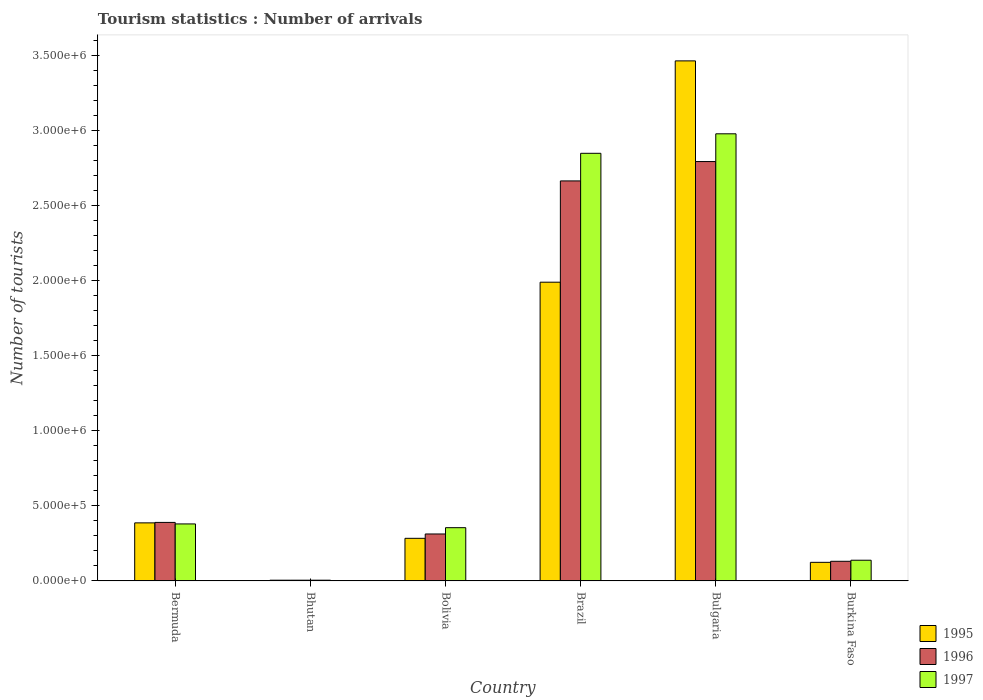How many different coloured bars are there?
Provide a short and direct response. 3. In how many cases, is the number of bars for a given country not equal to the number of legend labels?
Offer a very short reply. 0. What is the number of tourist arrivals in 1995 in Bulgaria?
Offer a terse response. 3.47e+06. Across all countries, what is the maximum number of tourist arrivals in 1997?
Make the answer very short. 2.98e+06. In which country was the number of tourist arrivals in 1995 maximum?
Your answer should be very brief. Bulgaria. In which country was the number of tourist arrivals in 1996 minimum?
Provide a short and direct response. Bhutan. What is the total number of tourist arrivals in 1995 in the graph?
Give a very brief answer. 6.26e+06. What is the difference between the number of tourist arrivals in 1997 in Bhutan and that in Bolivia?
Your answer should be very brief. -3.50e+05. What is the difference between the number of tourist arrivals in 1996 in Bhutan and the number of tourist arrivals in 1997 in Bermuda?
Your answer should be very brief. -3.75e+05. What is the average number of tourist arrivals in 1997 per country?
Offer a terse response. 1.12e+06. What is the difference between the number of tourist arrivals of/in 1996 and number of tourist arrivals of/in 1995 in Burkina Faso?
Your answer should be compact. 7000. In how many countries, is the number of tourist arrivals in 1997 greater than 2600000?
Provide a succinct answer. 2. What is the ratio of the number of tourist arrivals in 1996 in Bulgaria to that in Burkina Faso?
Your response must be concise. 21.34. Is the difference between the number of tourist arrivals in 1996 in Brazil and Bulgaria greater than the difference between the number of tourist arrivals in 1995 in Brazil and Bulgaria?
Keep it short and to the point. Yes. What is the difference between the highest and the second highest number of tourist arrivals in 1997?
Offer a very short reply. 2.60e+06. What is the difference between the highest and the lowest number of tourist arrivals in 1995?
Offer a very short reply. 3.46e+06. In how many countries, is the number of tourist arrivals in 1995 greater than the average number of tourist arrivals in 1995 taken over all countries?
Offer a very short reply. 2. Is the sum of the number of tourist arrivals in 1995 in Bermuda and Bolivia greater than the maximum number of tourist arrivals in 1997 across all countries?
Offer a very short reply. No. Is it the case that in every country, the sum of the number of tourist arrivals in 1995 and number of tourist arrivals in 1997 is greater than the number of tourist arrivals in 1996?
Offer a terse response. Yes. How many countries are there in the graph?
Make the answer very short. 6. What is the difference between two consecutive major ticks on the Y-axis?
Provide a short and direct response. 5.00e+05. Does the graph contain grids?
Offer a terse response. No. How many legend labels are there?
Keep it short and to the point. 3. What is the title of the graph?
Your answer should be very brief. Tourism statistics : Number of arrivals. What is the label or title of the X-axis?
Your response must be concise. Country. What is the label or title of the Y-axis?
Keep it short and to the point. Number of tourists. What is the Number of tourists in 1995 in Bermuda?
Provide a short and direct response. 3.87e+05. What is the Number of tourists in 1995 in Bhutan?
Your answer should be compact. 5000. What is the Number of tourists of 1995 in Bolivia?
Offer a very short reply. 2.84e+05. What is the Number of tourists of 1996 in Bolivia?
Give a very brief answer. 3.13e+05. What is the Number of tourists in 1997 in Bolivia?
Your answer should be very brief. 3.55e+05. What is the Number of tourists in 1995 in Brazil?
Your answer should be compact. 1.99e+06. What is the Number of tourists of 1996 in Brazil?
Offer a terse response. 2.67e+06. What is the Number of tourists in 1997 in Brazil?
Provide a succinct answer. 2.85e+06. What is the Number of tourists of 1995 in Bulgaria?
Make the answer very short. 3.47e+06. What is the Number of tourists of 1996 in Bulgaria?
Offer a very short reply. 2.80e+06. What is the Number of tourists of 1997 in Bulgaria?
Offer a very short reply. 2.98e+06. What is the Number of tourists of 1995 in Burkina Faso?
Keep it short and to the point. 1.24e+05. What is the Number of tourists in 1996 in Burkina Faso?
Your response must be concise. 1.31e+05. What is the Number of tourists of 1997 in Burkina Faso?
Your response must be concise. 1.38e+05. Across all countries, what is the maximum Number of tourists in 1995?
Keep it short and to the point. 3.47e+06. Across all countries, what is the maximum Number of tourists of 1996?
Make the answer very short. 2.80e+06. Across all countries, what is the maximum Number of tourists of 1997?
Make the answer very short. 2.98e+06. Across all countries, what is the minimum Number of tourists of 1995?
Give a very brief answer. 5000. Across all countries, what is the minimum Number of tourists in 1997?
Keep it short and to the point. 5000. What is the total Number of tourists of 1995 in the graph?
Your answer should be compact. 6.26e+06. What is the total Number of tourists in 1996 in the graph?
Ensure brevity in your answer.  6.30e+06. What is the total Number of tourists of 1997 in the graph?
Your response must be concise. 6.71e+06. What is the difference between the Number of tourists in 1995 in Bermuda and that in Bhutan?
Keep it short and to the point. 3.82e+05. What is the difference between the Number of tourists in 1996 in Bermuda and that in Bhutan?
Give a very brief answer. 3.85e+05. What is the difference between the Number of tourists of 1997 in Bermuda and that in Bhutan?
Ensure brevity in your answer.  3.75e+05. What is the difference between the Number of tourists of 1995 in Bermuda and that in Bolivia?
Offer a very short reply. 1.03e+05. What is the difference between the Number of tourists of 1996 in Bermuda and that in Bolivia?
Provide a short and direct response. 7.70e+04. What is the difference between the Number of tourists of 1997 in Bermuda and that in Bolivia?
Give a very brief answer. 2.50e+04. What is the difference between the Number of tourists of 1995 in Bermuda and that in Brazil?
Your response must be concise. -1.60e+06. What is the difference between the Number of tourists in 1996 in Bermuda and that in Brazil?
Your answer should be compact. -2.28e+06. What is the difference between the Number of tourists of 1997 in Bermuda and that in Brazil?
Keep it short and to the point. -2.47e+06. What is the difference between the Number of tourists of 1995 in Bermuda and that in Bulgaria?
Make the answer very short. -3.08e+06. What is the difference between the Number of tourists in 1996 in Bermuda and that in Bulgaria?
Your answer should be compact. -2.40e+06. What is the difference between the Number of tourists of 1997 in Bermuda and that in Bulgaria?
Offer a very short reply. -2.60e+06. What is the difference between the Number of tourists of 1995 in Bermuda and that in Burkina Faso?
Your answer should be very brief. 2.63e+05. What is the difference between the Number of tourists of 1996 in Bermuda and that in Burkina Faso?
Provide a succinct answer. 2.59e+05. What is the difference between the Number of tourists of 1997 in Bermuda and that in Burkina Faso?
Provide a succinct answer. 2.42e+05. What is the difference between the Number of tourists of 1995 in Bhutan and that in Bolivia?
Your response must be concise. -2.79e+05. What is the difference between the Number of tourists in 1996 in Bhutan and that in Bolivia?
Provide a short and direct response. -3.08e+05. What is the difference between the Number of tourists in 1997 in Bhutan and that in Bolivia?
Offer a terse response. -3.50e+05. What is the difference between the Number of tourists in 1995 in Bhutan and that in Brazil?
Ensure brevity in your answer.  -1.99e+06. What is the difference between the Number of tourists of 1996 in Bhutan and that in Brazil?
Your response must be concise. -2.66e+06. What is the difference between the Number of tourists of 1997 in Bhutan and that in Brazil?
Offer a terse response. -2.84e+06. What is the difference between the Number of tourists of 1995 in Bhutan and that in Bulgaria?
Your answer should be very brief. -3.46e+06. What is the difference between the Number of tourists in 1996 in Bhutan and that in Bulgaria?
Provide a succinct answer. -2.79e+06. What is the difference between the Number of tourists of 1997 in Bhutan and that in Bulgaria?
Offer a terse response. -2.98e+06. What is the difference between the Number of tourists of 1995 in Bhutan and that in Burkina Faso?
Offer a terse response. -1.19e+05. What is the difference between the Number of tourists in 1996 in Bhutan and that in Burkina Faso?
Make the answer very short. -1.26e+05. What is the difference between the Number of tourists of 1997 in Bhutan and that in Burkina Faso?
Provide a succinct answer. -1.33e+05. What is the difference between the Number of tourists of 1995 in Bolivia and that in Brazil?
Offer a terse response. -1.71e+06. What is the difference between the Number of tourists of 1996 in Bolivia and that in Brazil?
Ensure brevity in your answer.  -2.35e+06. What is the difference between the Number of tourists of 1997 in Bolivia and that in Brazil?
Make the answer very short. -2.50e+06. What is the difference between the Number of tourists of 1995 in Bolivia and that in Bulgaria?
Provide a succinct answer. -3.18e+06. What is the difference between the Number of tourists of 1996 in Bolivia and that in Bulgaria?
Your answer should be very brief. -2.48e+06. What is the difference between the Number of tourists of 1997 in Bolivia and that in Bulgaria?
Provide a short and direct response. -2.62e+06. What is the difference between the Number of tourists of 1995 in Bolivia and that in Burkina Faso?
Your response must be concise. 1.60e+05. What is the difference between the Number of tourists of 1996 in Bolivia and that in Burkina Faso?
Ensure brevity in your answer.  1.82e+05. What is the difference between the Number of tourists of 1997 in Bolivia and that in Burkina Faso?
Your response must be concise. 2.17e+05. What is the difference between the Number of tourists in 1995 in Brazil and that in Bulgaria?
Your response must be concise. -1.48e+06. What is the difference between the Number of tourists in 1996 in Brazil and that in Bulgaria?
Provide a short and direct response. -1.29e+05. What is the difference between the Number of tourists in 1995 in Brazil and that in Burkina Faso?
Provide a short and direct response. 1.87e+06. What is the difference between the Number of tourists of 1996 in Brazil and that in Burkina Faso?
Give a very brief answer. 2.54e+06. What is the difference between the Number of tourists of 1997 in Brazil and that in Burkina Faso?
Your response must be concise. 2.71e+06. What is the difference between the Number of tourists in 1995 in Bulgaria and that in Burkina Faso?
Ensure brevity in your answer.  3.34e+06. What is the difference between the Number of tourists of 1996 in Bulgaria and that in Burkina Faso?
Give a very brief answer. 2.66e+06. What is the difference between the Number of tourists of 1997 in Bulgaria and that in Burkina Faso?
Your response must be concise. 2.84e+06. What is the difference between the Number of tourists in 1995 in Bermuda and the Number of tourists in 1996 in Bhutan?
Give a very brief answer. 3.82e+05. What is the difference between the Number of tourists of 1995 in Bermuda and the Number of tourists of 1997 in Bhutan?
Your answer should be compact. 3.82e+05. What is the difference between the Number of tourists in 1996 in Bermuda and the Number of tourists in 1997 in Bhutan?
Your answer should be very brief. 3.85e+05. What is the difference between the Number of tourists in 1995 in Bermuda and the Number of tourists in 1996 in Bolivia?
Give a very brief answer. 7.40e+04. What is the difference between the Number of tourists of 1995 in Bermuda and the Number of tourists of 1997 in Bolivia?
Provide a short and direct response. 3.20e+04. What is the difference between the Number of tourists of 1996 in Bermuda and the Number of tourists of 1997 in Bolivia?
Your answer should be very brief. 3.50e+04. What is the difference between the Number of tourists in 1995 in Bermuda and the Number of tourists in 1996 in Brazil?
Your response must be concise. -2.28e+06. What is the difference between the Number of tourists in 1995 in Bermuda and the Number of tourists in 1997 in Brazil?
Ensure brevity in your answer.  -2.46e+06. What is the difference between the Number of tourists of 1996 in Bermuda and the Number of tourists of 1997 in Brazil?
Keep it short and to the point. -2.46e+06. What is the difference between the Number of tourists of 1995 in Bermuda and the Number of tourists of 1996 in Bulgaria?
Keep it short and to the point. -2.41e+06. What is the difference between the Number of tourists in 1995 in Bermuda and the Number of tourists in 1997 in Bulgaria?
Make the answer very short. -2.59e+06. What is the difference between the Number of tourists of 1996 in Bermuda and the Number of tourists of 1997 in Bulgaria?
Offer a terse response. -2.59e+06. What is the difference between the Number of tourists in 1995 in Bermuda and the Number of tourists in 1996 in Burkina Faso?
Provide a succinct answer. 2.56e+05. What is the difference between the Number of tourists in 1995 in Bermuda and the Number of tourists in 1997 in Burkina Faso?
Your answer should be compact. 2.49e+05. What is the difference between the Number of tourists of 1996 in Bermuda and the Number of tourists of 1997 in Burkina Faso?
Your answer should be very brief. 2.52e+05. What is the difference between the Number of tourists in 1995 in Bhutan and the Number of tourists in 1996 in Bolivia?
Keep it short and to the point. -3.08e+05. What is the difference between the Number of tourists in 1995 in Bhutan and the Number of tourists in 1997 in Bolivia?
Provide a short and direct response. -3.50e+05. What is the difference between the Number of tourists in 1996 in Bhutan and the Number of tourists in 1997 in Bolivia?
Offer a very short reply. -3.50e+05. What is the difference between the Number of tourists in 1995 in Bhutan and the Number of tourists in 1996 in Brazil?
Keep it short and to the point. -2.66e+06. What is the difference between the Number of tourists of 1995 in Bhutan and the Number of tourists of 1997 in Brazil?
Ensure brevity in your answer.  -2.84e+06. What is the difference between the Number of tourists of 1996 in Bhutan and the Number of tourists of 1997 in Brazil?
Your response must be concise. -2.84e+06. What is the difference between the Number of tourists in 1995 in Bhutan and the Number of tourists in 1996 in Bulgaria?
Offer a very short reply. -2.79e+06. What is the difference between the Number of tourists of 1995 in Bhutan and the Number of tourists of 1997 in Bulgaria?
Provide a short and direct response. -2.98e+06. What is the difference between the Number of tourists in 1996 in Bhutan and the Number of tourists in 1997 in Bulgaria?
Provide a succinct answer. -2.98e+06. What is the difference between the Number of tourists of 1995 in Bhutan and the Number of tourists of 1996 in Burkina Faso?
Ensure brevity in your answer.  -1.26e+05. What is the difference between the Number of tourists of 1995 in Bhutan and the Number of tourists of 1997 in Burkina Faso?
Your answer should be very brief. -1.33e+05. What is the difference between the Number of tourists in 1996 in Bhutan and the Number of tourists in 1997 in Burkina Faso?
Offer a terse response. -1.33e+05. What is the difference between the Number of tourists of 1995 in Bolivia and the Number of tourists of 1996 in Brazil?
Your answer should be compact. -2.38e+06. What is the difference between the Number of tourists in 1995 in Bolivia and the Number of tourists in 1997 in Brazil?
Offer a very short reply. -2.57e+06. What is the difference between the Number of tourists of 1996 in Bolivia and the Number of tourists of 1997 in Brazil?
Provide a short and direct response. -2.54e+06. What is the difference between the Number of tourists in 1995 in Bolivia and the Number of tourists in 1996 in Bulgaria?
Make the answer very short. -2.51e+06. What is the difference between the Number of tourists of 1995 in Bolivia and the Number of tourists of 1997 in Bulgaria?
Your answer should be very brief. -2.70e+06. What is the difference between the Number of tourists in 1996 in Bolivia and the Number of tourists in 1997 in Bulgaria?
Your response must be concise. -2.67e+06. What is the difference between the Number of tourists of 1995 in Bolivia and the Number of tourists of 1996 in Burkina Faso?
Make the answer very short. 1.53e+05. What is the difference between the Number of tourists of 1995 in Bolivia and the Number of tourists of 1997 in Burkina Faso?
Provide a succinct answer. 1.46e+05. What is the difference between the Number of tourists of 1996 in Bolivia and the Number of tourists of 1997 in Burkina Faso?
Provide a succinct answer. 1.75e+05. What is the difference between the Number of tourists of 1995 in Brazil and the Number of tourists of 1996 in Bulgaria?
Keep it short and to the point. -8.04e+05. What is the difference between the Number of tourists in 1995 in Brazil and the Number of tourists in 1997 in Bulgaria?
Provide a short and direct response. -9.89e+05. What is the difference between the Number of tourists in 1996 in Brazil and the Number of tourists in 1997 in Bulgaria?
Your answer should be very brief. -3.14e+05. What is the difference between the Number of tourists of 1995 in Brazil and the Number of tourists of 1996 in Burkina Faso?
Offer a terse response. 1.86e+06. What is the difference between the Number of tourists in 1995 in Brazil and the Number of tourists in 1997 in Burkina Faso?
Give a very brief answer. 1.85e+06. What is the difference between the Number of tourists of 1996 in Brazil and the Number of tourists of 1997 in Burkina Faso?
Give a very brief answer. 2.53e+06. What is the difference between the Number of tourists of 1995 in Bulgaria and the Number of tourists of 1996 in Burkina Faso?
Your answer should be compact. 3.34e+06. What is the difference between the Number of tourists in 1995 in Bulgaria and the Number of tourists in 1997 in Burkina Faso?
Provide a short and direct response. 3.33e+06. What is the difference between the Number of tourists in 1996 in Bulgaria and the Number of tourists in 1997 in Burkina Faso?
Keep it short and to the point. 2.66e+06. What is the average Number of tourists of 1995 per country?
Offer a terse response. 1.04e+06. What is the average Number of tourists in 1996 per country?
Offer a very short reply. 1.05e+06. What is the average Number of tourists in 1997 per country?
Keep it short and to the point. 1.12e+06. What is the difference between the Number of tourists of 1995 and Number of tourists of 1996 in Bermuda?
Ensure brevity in your answer.  -3000. What is the difference between the Number of tourists of 1995 and Number of tourists of 1997 in Bermuda?
Your answer should be very brief. 7000. What is the difference between the Number of tourists of 1996 and Number of tourists of 1997 in Bermuda?
Give a very brief answer. 10000. What is the difference between the Number of tourists of 1995 and Number of tourists of 1996 in Bhutan?
Your answer should be very brief. 0. What is the difference between the Number of tourists of 1995 and Number of tourists of 1997 in Bhutan?
Your response must be concise. 0. What is the difference between the Number of tourists in 1996 and Number of tourists in 1997 in Bhutan?
Offer a terse response. 0. What is the difference between the Number of tourists in 1995 and Number of tourists in 1996 in Bolivia?
Provide a succinct answer. -2.90e+04. What is the difference between the Number of tourists of 1995 and Number of tourists of 1997 in Bolivia?
Your answer should be very brief. -7.10e+04. What is the difference between the Number of tourists of 1996 and Number of tourists of 1997 in Bolivia?
Make the answer very short. -4.20e+04. What is the difference between the Number of tourists in 1995 and Number of tourists in 1996 in Brazil?
Keep it short and to the point. -6.75e+05. What is the difference between the Number of tourists of 1995 and Number of tourists of 1997 in Brazil?
Your answer should be compact. -8.59e+05. What is the difference between the Number of tourists in 1996 and Number of tourists in 1997 in Brazil?
Offer a terse response. -1.84e+05. What is the difference between the Number of tourists of 1995 and Number of tourists of 1996 in Bulgaria?
Give a very brief answer. 6.71e+05. What is the difference between the Number of tourists in 1995 and Number of tourists in 1997 in Bulgaria?
Provide a succinct answer. 4.86e+05. What is the difference between the Number of tourists of 1996 and Number of tourists of 1997 in Bulgaria?
Ensure brevity in your answer.  -1.85e+05. What is the difference between the Number of tourists of 1995 and Number of tourists of 1996 in Burkina Faso?
Make the answer very short. -7000. What is the difference between the Number of tourists in 1995 and Number of tourists in 1997 in Burkina Faso?
Provide a short and direct response. -1.40e+04. What is the difference between the Number of tourists of 1996 and Number of tourists of 1997 in Burkina Faso?
Provide a succinct answer. -7000. What is the ratio of the Number of tourists of 1995 in Bermuda to that in Bhutan?
Provide a short and direct response. 77.4. What is the ratio of the Number of tourists of 1996 in Bermuda to that in Bhutan?
Your answer should be compact. 78. What is the ratio of the Number of tourists in 1995 in Bermuda to that in Bolivia?
Offer a very short reply. 1.36. What is the ratio of the Number of tourists of 1996 in Bermuda to that in Bolivia?
Your response must be concise. 1.25. What is the ratio of the Number of tourists of 1997 in Bermuda to that in Bolivia?
Offer a very short reply. 1.07. What is the ratio of the Number of tourists of 1995 in Bermuda to that in Brazil?
Keep it short and to the point. 0.19. What is the ratio of the Number of tourists in 1996 in Bermuda to that in Brazil?
Your answer should be very brief. 0.15. What is the ratio of the Number of tourists of 1997 in Bermuda to that in Brazil?
Offer a terse response. 0.13. What is the ratio of the Number of tourists in 1995 in Bermuda to that in Bulgaria?
Provide a short and direct response. 0.11. What is the ratio of the Number of tourists of 1996 in Bermuda to that in Bulgaria?
Your response must be concise. 0.14. What is the ratio of the Number of tourists in 1997 in Bermuda to that in Bulgaria?
Provide a succinct answer. 0.13. What is the ratio of the Number of tourists of 1995 in Bermuda to that in Burkina Faso?
Provide a short and direct response. 3.12. What is the ratio of the Number of tourists of 1996 in Bermuda to that in Burkina Faso?
Your answer should be very brief. 2.98. What is the ratio of the Number of tourists in 1997 in Bermuda to that in Burkina Faso?
Ensure brevity in your answer.  2.75. What is the ratio of the Number of tourists in 1995 in Bhutan to that in Bolivia?
Ensure brevity in your answer.  0.02. What is the ratio of the Number of tourists in 1996 in Bhutan to that in Bolivia?
Keep it short and to the point. 0.02. What is the ratio of the Number of tourists in 1997 in Bhutan to that in Bolivia?
Offer a terse response. 0.01. What is the ratio of the Number of tourists of 1995 in Bhutan to that in Brazil?
Provide a short and direct response. 0. What is the ratio of the Number of tourists in 1996 in Bhutan to that in Brazil?
Make the answer very short. 0. What is the ratio of the Number of tourists in 1997 in Bhutan to that in Brazil?
Your answer should be compact. 0. What is the ratio of the Number of tourists in 1995 in Bhutan to that in Bulgaria?
Offer a terse response. 0. What is the ratio of the Number of tourists in 1996 in Bhutan to that in Bulgaria?
Offer a very short reply. 0. What is the ratio of the Number of tourists of 1997 in Bhutan to that in Bulgaria?
Offer a terse response. 0. What is the ratio of the Number of tourists in 1995 in Bhutan to that in Burkina Faso?
Ensure brevity in your answer.  0.04. What is the ratio of the Number of tourists of 1996 in Bhutan to that in Burkina Faso?
Your answer should be compact. 0.04. What is the ratio of the Number of tourists of 1997 in Bhutan to that in Burkina Faso?
Give a very brief answer. 0.04. What is the ratio of the Number of tourists of 1995 in Bolivia to that in Brazil?
Provide a succinct answer. 0.14. What is the ratio of the Number of tourists of 1996 in Bolivia to that in Brazil?
Make the answer very short. 0.12. What is the ratio of the Number of tourists in 1997 in Bolivia to that in Brazil?
Your answer should be very brief. 0.12. What is the ratio of the Number of tourists of 1995 in Bolivia to that in Bulgaria?
Your answer should be very brief. 0.08. What is the ratio of the Number of tourists of 1996 in Bolivia to that in Bulgaria?
Your answer should be compact. 0.11. What is the ratio of the Number of tourists of 1997 in Bolivia to that in Bulgaria?
Offer a terse response. 0.12. What is the ratio of the Number of tourists of 1995 in Bolivia to that in Burkina Faso?
Your answer should be compact. 2.29. What is the ratio of the Number of tourists of 1996 in Bolivia to that in Burkina Faso?
Keep it short and to the point. 2.39. What is the ratio of the Number of tourists of 1997 in Bolivia to that in Burkina Faso?
Give a very brief answer. 2.57. What is the ratio of the Number of tourists in 1995 in Brazil to that in Bulgaria?
Your answer should be very brief. 0.57. What is the ratio of the Number of tourists in 1996 in Brazil to that in Bulgaria?
Make the answer very short. 0.95. What is the ratio of the Number of tourists of 1997 in Brazil to that in Bulgaria?
Your answer should be compact. 0.96. What is the ratio of the Number of tourists of 1995 in Brazil to that in Burkina Faso?
Your answer should be very brief. 16.06. What is the ratio of the Number of tourists in 1996 in Brazil to that in Burkina Faso?
Provide a succinct answer. 20.35. What is the ratio of the Number of tourists of 1997 in Brazil to that in Burkina Faso?
Offer a very short reply. 20.65. What is the ratio of the Number of tourists in 1995 in Bulgaria to that in Burkina Faso?
Keep it short and to the point. 27.95. What is the ratio of the Number of tourists in 1996 in Bulgaria to that in Burkina Faso?
Keep it short and to the point. 21.34. What is the ratio of the Number of tourists in 1997 in Bulgaria to that in Burkina Faso?
Your answer should be very brief. 21.59. What is the difference between the highest and the second highest Number of tourists in 1995?
Give a very brief answer. 1.48e+06. What is the difference between the highest and the second highest Number of tourists of 1996?
Your answer should be compact. 1.29e+05. What is the difference between the highest and the second highest Number of tourists in 1997?
Your response must be concise. 1.30e+05. What is the difference between the highest and the lowest Number of tourists of 1995?
Give a very brief answer. 3.46e+06. What is the difference between the highest and the lowest Number of tourists in 1996?
Make the answer very short. 2.79e+06. What is the difference between the highest and the lowest Number of tourists in 1997?
Your answer should be very brief. 2.98e+06. 